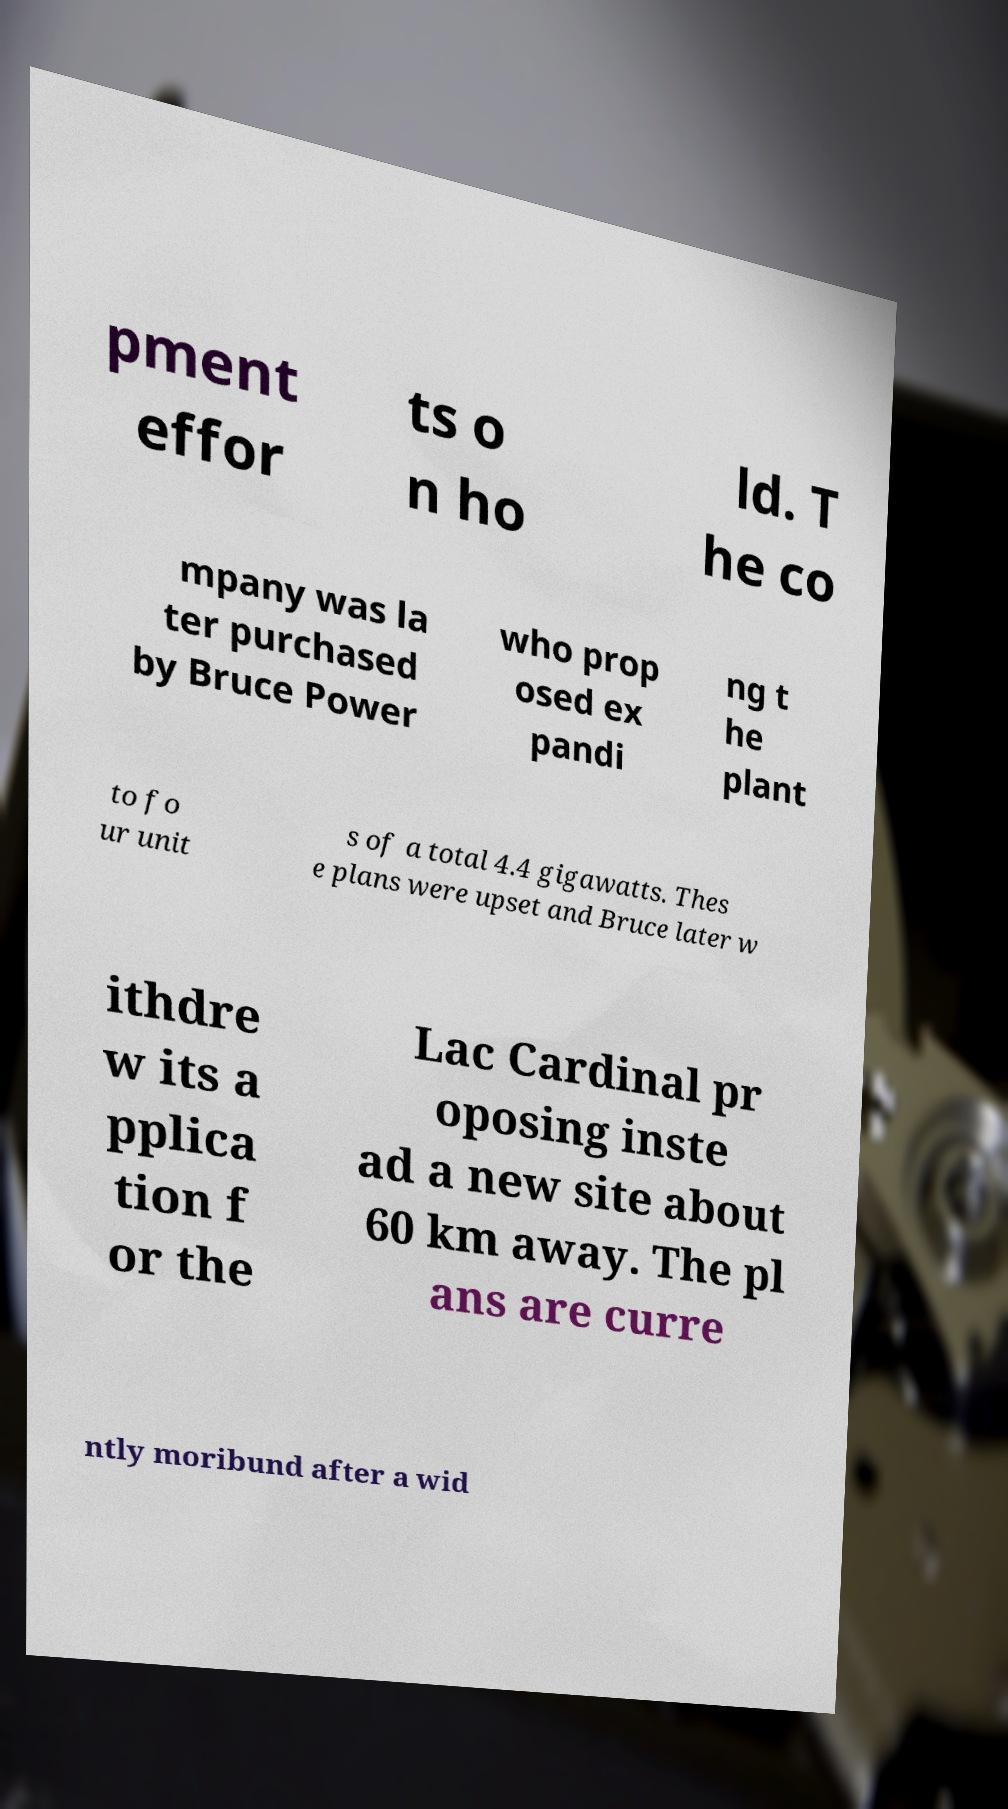I need the written content from this picture converted into text. Can you do that? pment effor ts o n ho ld. T he co mpany was la ter purchased by Bruce Power who prop osed ex pandi ng t he plant to fo ur unit s of a total 4.4 gigawatts. Thes e plans were upset and Bruce later w ithdre w its a pplica tion f or the Lac Cardinal pr oposing inste ad a new site about 60 km away. The pl ans are curre ntly moribund after a wid 